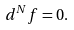<formula> <loc_0><loc_0><loc_500><loc_500>d ^ { N } f = 0 .</formula> 